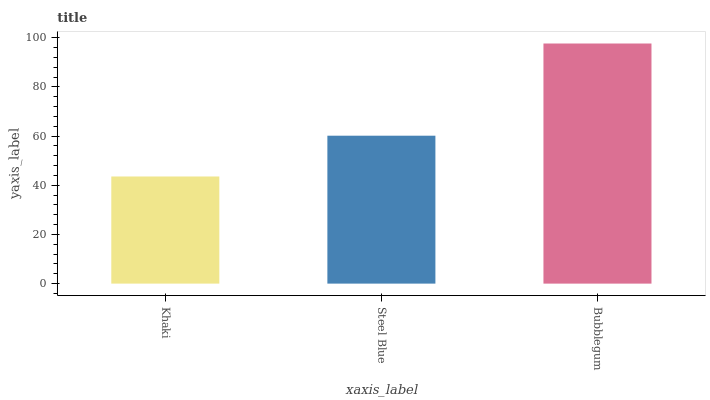Is Khaki the minimum?
Answer yes or no. Yes. Is Bubblegum the maximum?
Answer yes or no. Yes. Is Steel Blue the minimum?
Answer yes or no. No. Is Steel Blue the maximum?
Answer yes or no. No. Is Steel Blue greater than Khaki?
Answer yes or no. Yes. Is Khaki less than Steel Blue?
Answer yes or no. Yes. Is Khaki greater than Steel Blue?
Answer yes or no. No. Is Steel Blue less than Khaki?
Answer yes or no. No. Is Steel Blue the high median?
Answer yes or no. Yes. Is Steel Blue the low median?
Answer yes or no. Yes. Is Khaki the high median?
Answer yes or no. No. Is Bubblegum the low median?
Answer yes or no. No. 